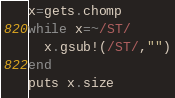Convert code to text. <code><loc_0><loc_0><loc_500><loc_500><_Ruby_>x=gets.chomp
while x=~/ST/
  x.gsub!(/ST/,"")
end
puts x.size
</code> 